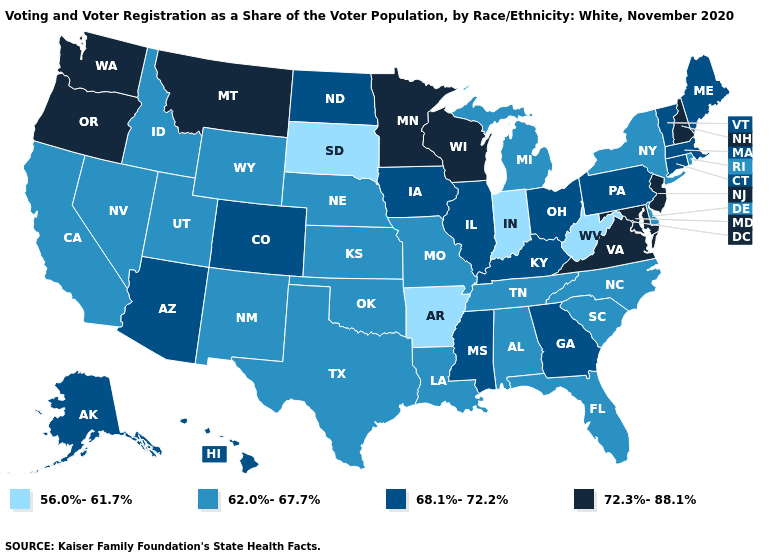Name the states that have a value in the range 62.0%-67.7%?
Keep it brief. Alabama, California, Delaware, Florida, Idaho, Kansas, Louisiana, Michigan, Missouri, Nebraska, Nevada, New Mexico, New York, North Carolina, Oklahoma, Rhode Island, South Carolina, Tennessee, Texas, Utah, Wyoming. What is the highest value in the USA?
Keep it brief. 72.3%-88.1%. Does South Dakota have the lowest value in the USA?
Write a very short answer. Yes. Among the states that border Oregon , does Washington have the lowest value?
Write a very short answer. No. Name the states that have a value in the range 62.0%-67.7%?
Give a very brief answer. Alabama, California, Delaware, Florida, Idaho, Kansas, Louisiana, Michigan, Missouri, Nebraska, Nevada, New Mexico, New York, North Carolina, Oklahoma, Rhode Island, South Carolina, Tennessee, Texas, Utah, Wyoming. Among the states that border South Carolina , which have the lowest value?
Answer briefly. North Carolina. What is the value of New Mexico?
Short answer required. 62.0%-67.7%. What is the lowest value in the MidWest?
Concise answer only. 56.0%-61.7%. What is the highest value in states that border North Carolina?
Concise answer only. 72.3%-88.1%. Name the states that have a value in the range 68.1%-72.2%?
Quick response, please. Alaska, Arizona, Colorado, Connecticut, Georgia, Hawaii, Illinois, Iowa, Kentucky, Maine, Massachusetts, Mississippi, North Dakota, Ohio, Pennsylvania, Vermont. Does Arkansas have the lowest value in the South?
Keep it brief. Yes. Does Massachusetts have the lowest value in the USA?
Concise answer only. No. Which states have the lowest value in the USA?
Answer briefly. Arkansas, Indiana, South Dakota, West Virginia. Is the legend a continuous bar?
Short answer required. No. How many symbols are there in the legend?
Quick response, please. 4. 